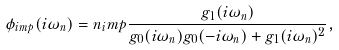Convert formula to latex. <formula><loc_0><loc_0><loc_500><loc_500>\phi _ { i m p } ( i \omega _ { n } ) = n _ { i } m p \frac { g _ { 1 } ( i \omega _ { n } ) } { g _ { 0 } ( i \omega _ { n } ) g _ { 0 } ( - i \omega _ { n } ) + g _ { 1 } ( i \omega _ { n } ) ^ { 2 } } ,</formula> 